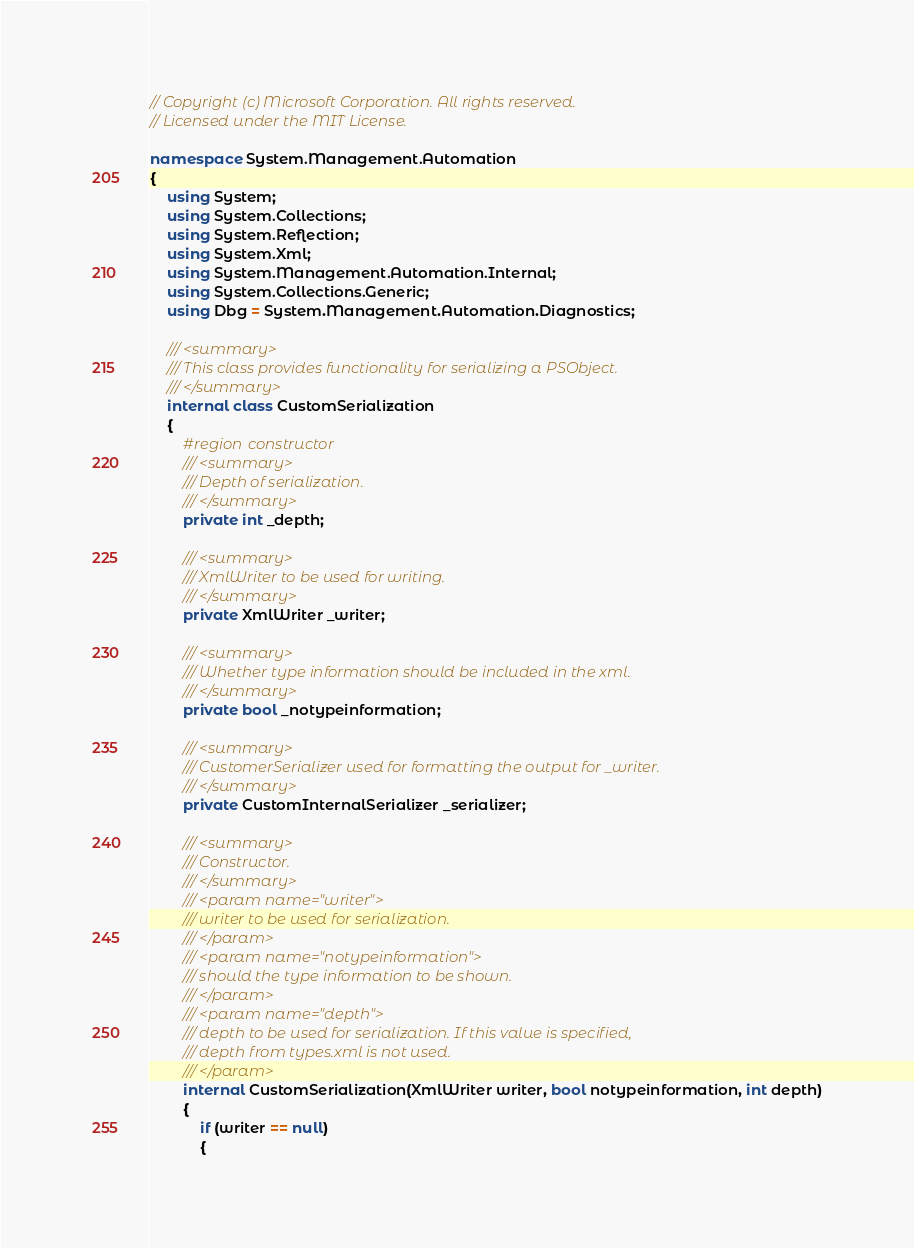Convert code to text. <code><loc_0><loc_0><loc_500><loc_500><_C#_>// Copyright (c) Microsoft Corporation. All rights reserved.
// Licensed under the MIT License.

namespace System.Management.Automation
{
    using System;
    using System.Collections;
    using System.Reflection;
    using System.Xml;
    using System.Management.Automation.Internal;
    using System.Collections.Generic;
    using Dbg = System.Management.Automation.Diagnostics;

    /// <summary>
    /// This class provides functionality for serializing a PSObject.
    /// </summary>
    internal class CustomSerialization
    {
        #region constructor
        /// <summary>
        /// Depth of serialization.
        /// </summary>
        private int _depth;

        /// <summary>
        /// XmlWriter to be used for writing.
        /// </summary>
        private XmlWriter _writer;

        /// <summary>
        /// Whether type information should be included in the xml.
        /// </summary>
        private bool _notypeinformation;

        /// <summary>
        /// CustomerSerializer used for formatting the output for _writer.
        /// </summary>
        private CustomInternalSerializer _serializer;

        /// <summary>
        /// Constructor.
        /// </summary>
        /// <param name="writer">
        /// writer to be used for serialization.
        /// </param>
        /// <param name="notypeinformation">
        /// should the type information to be shown.
        /// </param>
        /// <param name="depth">
        /// depth to be used for serialization. If this value is specified,
        /// depth from types.xml is not used.
        /// </param>
        internal CustomSerialization(XmlWriter writer, bool notypeinformation, int depth)
        {
            if (writer == null)
            {</code> 